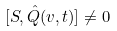Convert formula to latex. <formula><loc_0><loc_0><loc_500><loc_500>[ S , \hat { Q } ( v , t ) ] \neq 0</formula> 